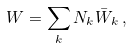<formula> <loc_0><loc_0><loc_500><loc_500>W = \sum _ { k } N _ { k } \bar { W } _ { k } \, ,</formula> 